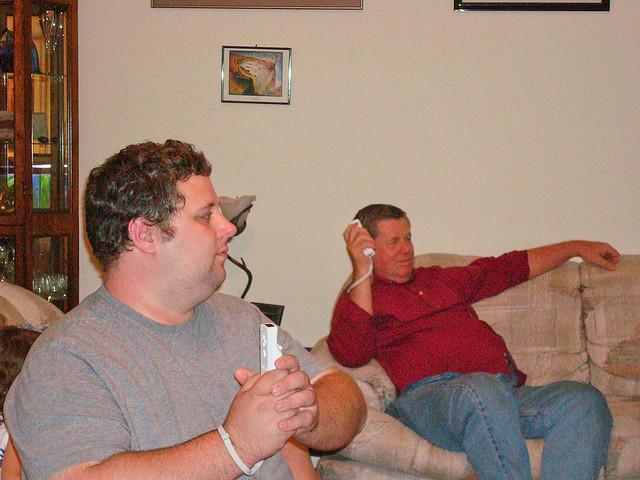What are the two men doing together?

Choices:
A) drawing
B) singing
C) playing instruments
D) gaming gaming 